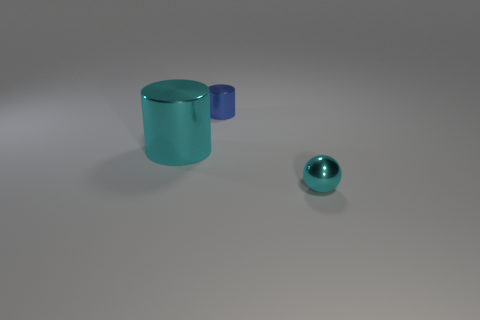What number of large metal objects are the same color as the metallic sphere?
Your answer should be compact. 1. What is the size of the shiny object that is the same color as the small ball?
Provide a succinct answer. Large. The large cylinder is what color?
Offer a terse response. Cyan. There is a small metallic object in front of the cyan cylinder; is it the same shape as the large cyan shiny thing?
Ensure brevity in your answer.  No. There is a small metal thing on the left side of the cyan metallic object on the right side of the cyan thing to the left of the small blue cylinder; what is its shape?
Give a very brief answer. Cylinder. What is the small thing that is behind the big cyan thing made of?
Ensure brevity in your answer.  Metal. What is the color of the sphere that is the same size as the blue metallic object?
Give a very brief answer. Cyan. What number of other things are there of the same shape as the large object?
Ensure brevity in your answer.  1. Is the size of the blue metallic cylinder the same as the cyan metal cylinder?
Your answer should be very brief. No. Are there more cyan things on the left side of the shiny sphere than tiny shiny spheres that are behind the small blue cylinder?
Ensure brevity in your answer.  Yes. 